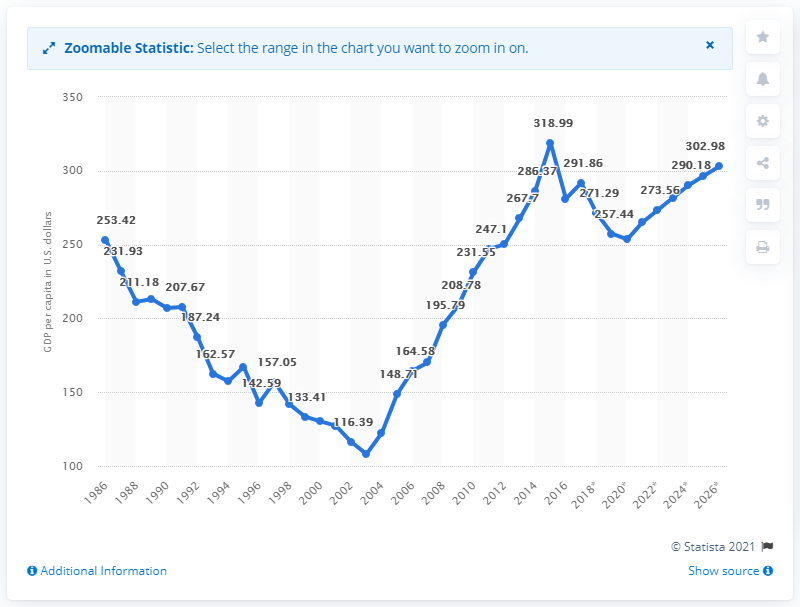List a handful of essential elements in this visual. In 2019, the GDP per capita in Burundi was 257.44. 